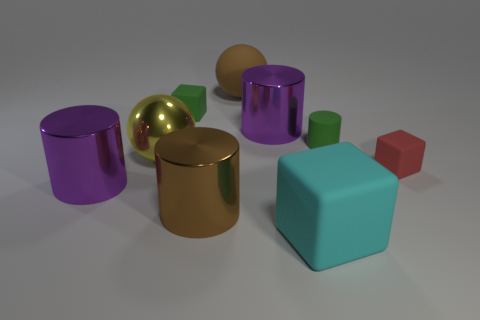Subtract all red spheres. Subtract all brown cylinders. How many spheres are left? 2 Add 1 big shiny things. How many objects exist? 10 Subtract all balls. How many objects are left? 7 Add 9 small gray metal objects. How many small gray metal objects exist? 9 Subtract 0 gray cylinders. How many objects are left? 9 Subtract all small green things. Subtract all small red rubber things. How many objects are left? 6 Add 4 purple cylinders. How many purple cylinders are left? 6 